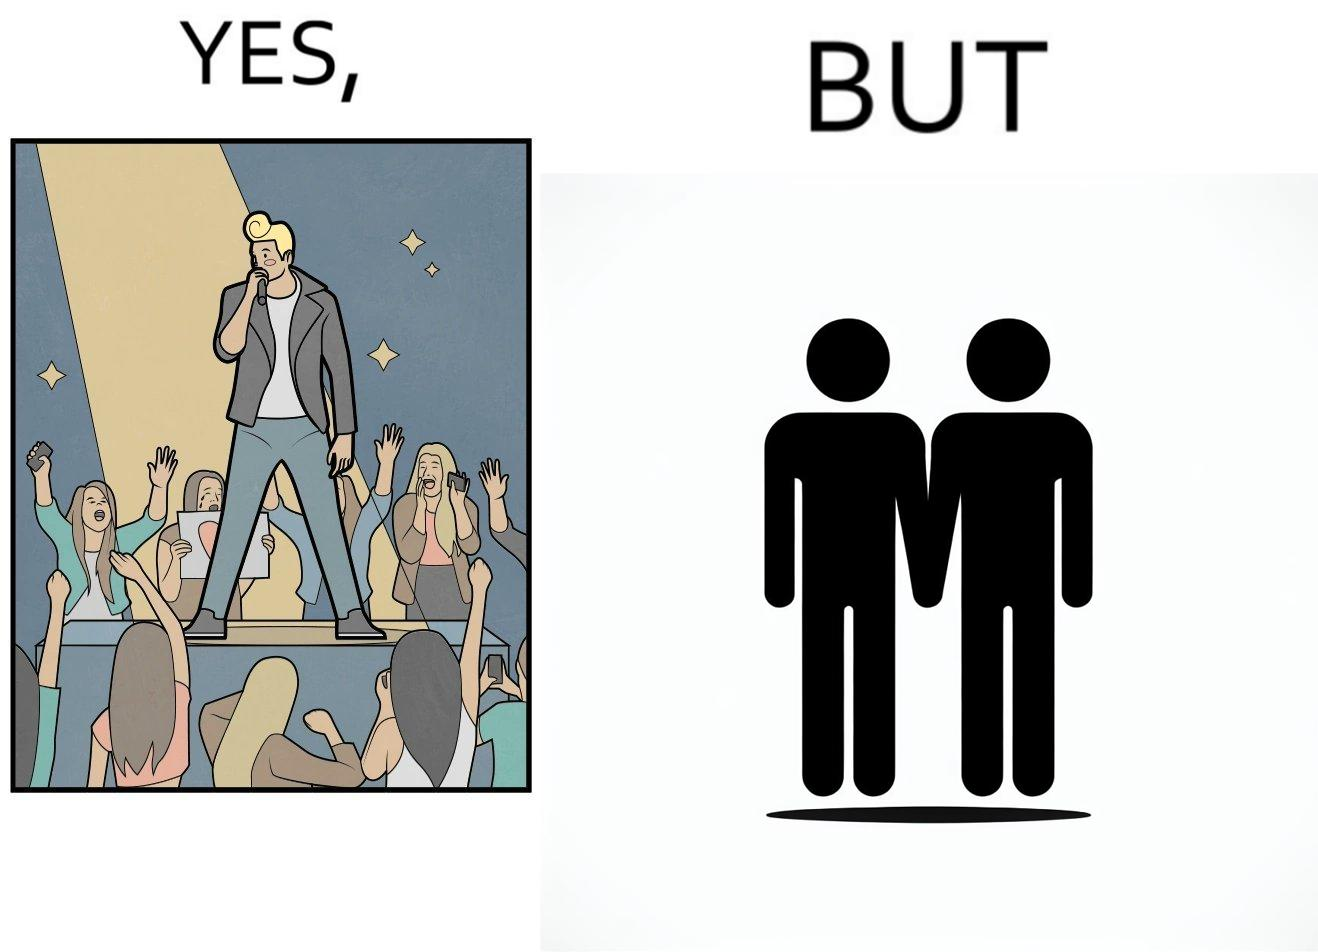What is the satirical meaning behind this image? The image is funny because while the girls loves the man, he likes other men instead of women. 